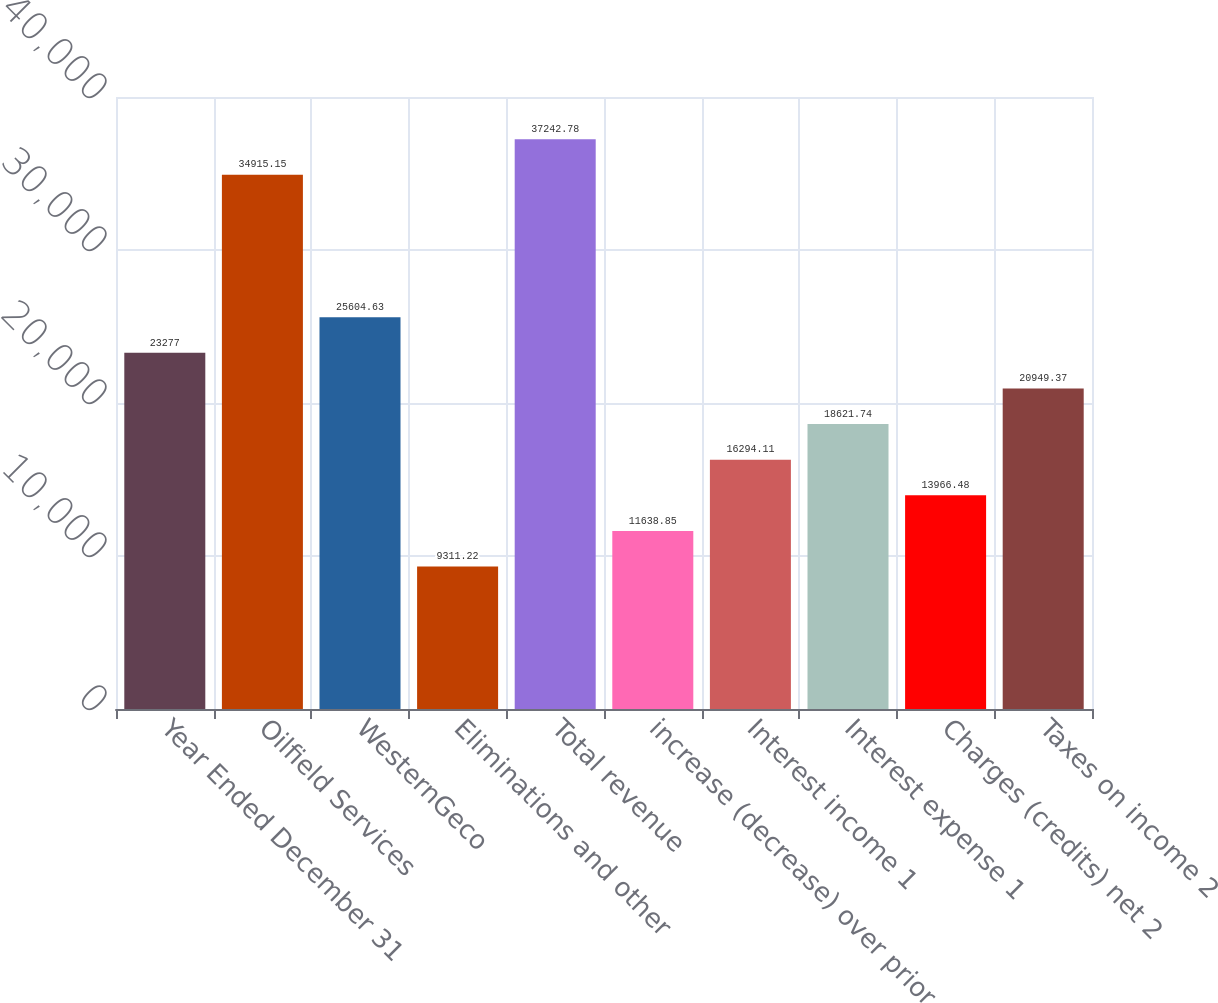Convert chart. <chart><loc_0><loc_0><loc_500><loc_500><bar_chart><fcel>Year Ended December 31<fcel>Oilfield Services<fcel>WesternGeco<fcel>Eliminations and other<fcel>Total revenue<fcel>increase (decrease) over prior<fcel>Interest income 1<fcel>Interest expense 1<fcel>Charges (credits) net 2<fcel>Taxes on income 2<nl><fcel>23277<fcel>34915.2<fcel>25604.6<fcel>9311.22<fcel>37242.8<fcel>11638.9<fcel>16294.1<fcel>18621.7<fcel>13966.5<fcel>20949.4<nl></chart> 